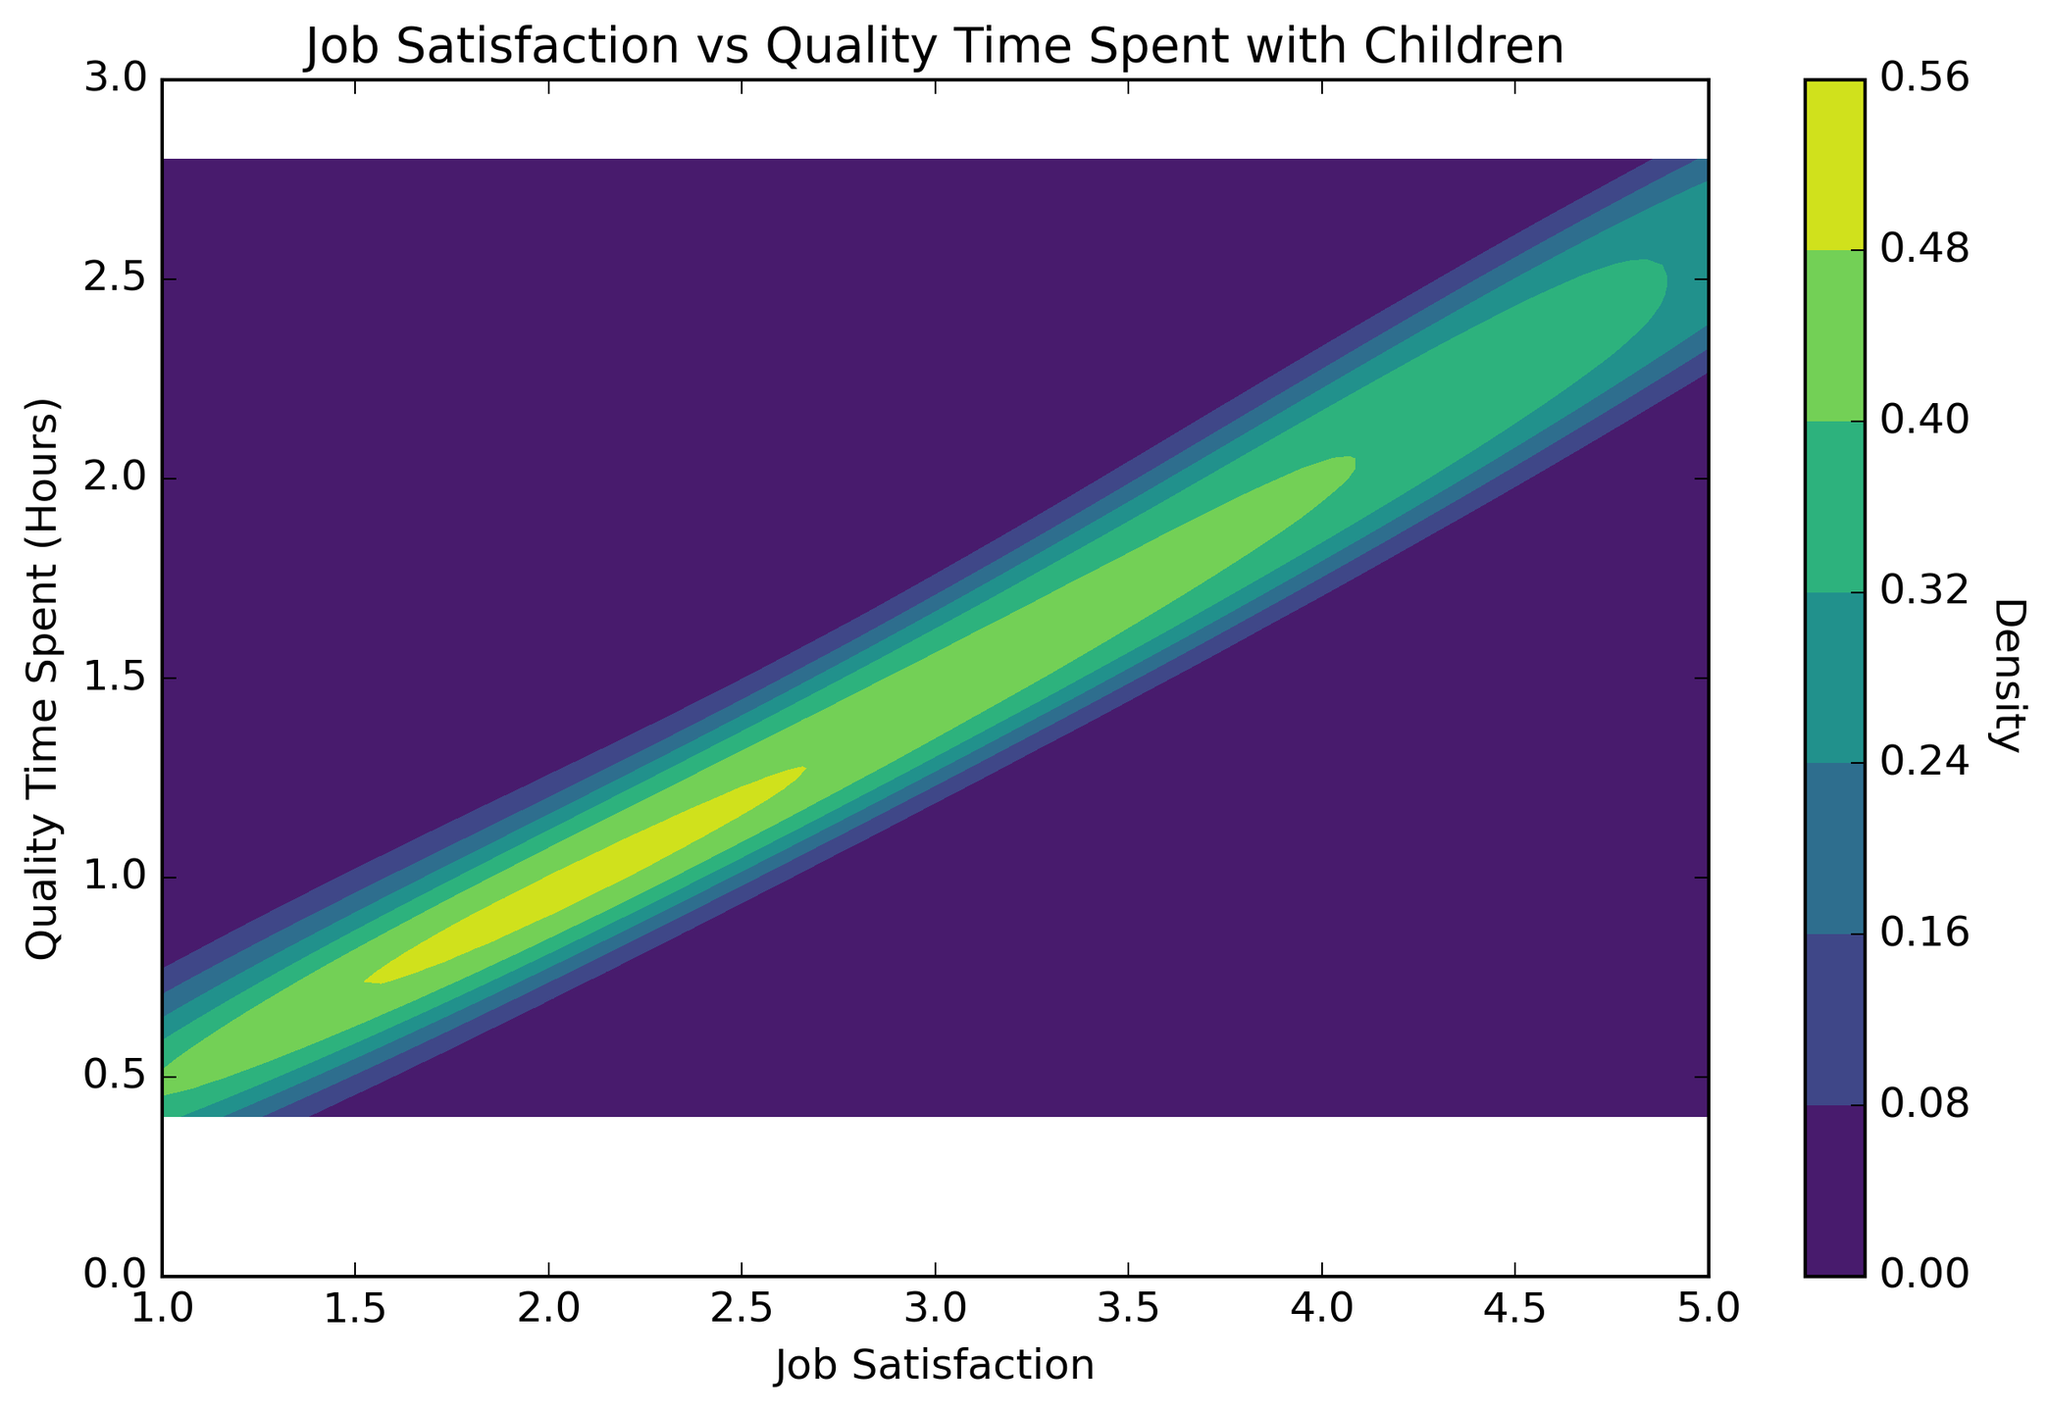How does the density of data points change with job satisfaction and quality time spent? By examining the contour plot, you can observe the density variations through the color gradient on the plot. The density of data points increases as the colors transition from light to dark shades on the 'viridis' color map.
Answer: It shows higher density regions around job satisfaction levels of 4 What is the range of quality time spent with children at job satisfaction level 3? Look at the contour lines around job satisfaction level 3 and observe the y-axis range they cover. The quality time ranges between approximately 1.3 to 1.6 hours.
Answer: 1.3 to 1.6 hours Which job satisfaction level shows the highest variability in quality time spent with children? By examining the spread of contour lines horizontally along the y-axis for each job satisfaction level, the level with the widest spread indicates the highest variability. Job satisfaction level 5 shows the largest spread.
Answer: Level 5 How does quality time spent change from job satisfaction level 1 to 5? Check the contour lines and the transition along the x-axis from job satisfaction level 1 to 5. As job satisfaction increases, the quality time spent with children also generally increases, showing a positive correlation.
Answer: Increases Which job satisfaction level has the highest concentration of quality time spent around 2 hours? Identify the contour lines around the 2-hour mark on the y-axis and see which job satisfaction level corresponds to the densest part of the contour plot. The highest density is around job satisfaction level 4.
Answer: Level 4 What is the approximate median value of quality time spent at job satisfaction level 2? At job satisfaction level 2, examine the central part of the contour lines and estimate the middle value along the y-axis. The median value appears to be around 0.9 hours.
Answer: 0.9 hours 